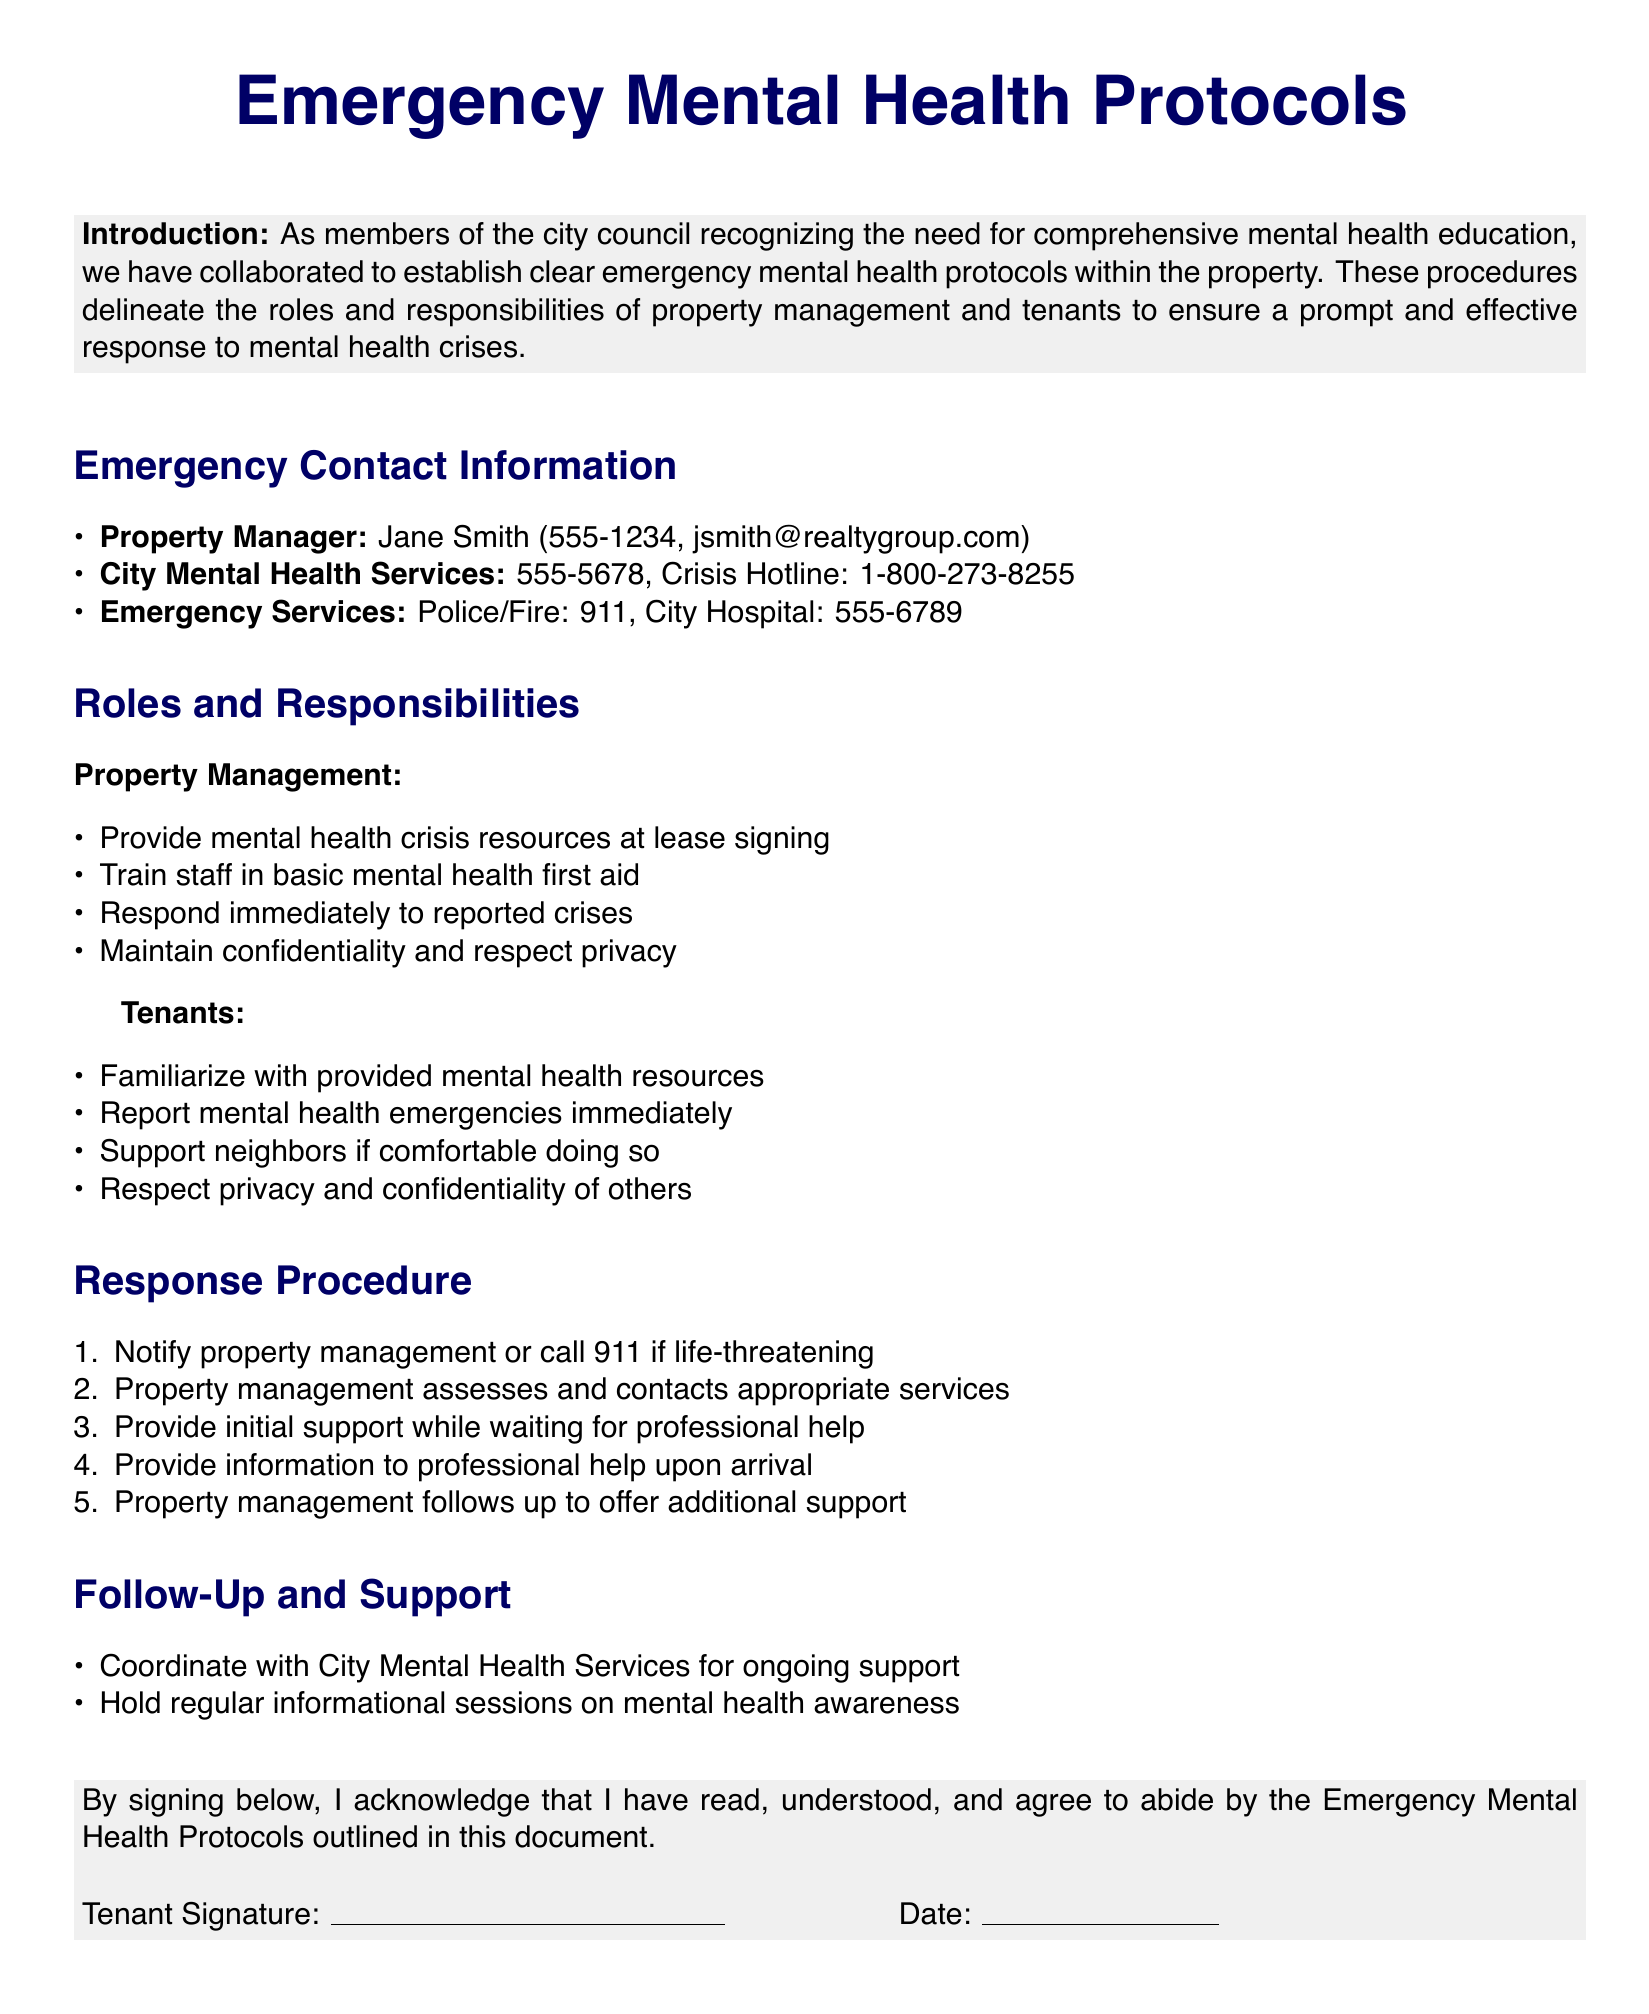What is the name of the property manager? The property manager's name is listed in the document under "Emergency Contact Information."
Answer: Jane Smith What is the phone number for City Mental Health Services? The phone number for City Mental Health Services is found in the emergency contact information section.
Answer: 555-5678 What should tenants do if they are aware of a mental health emergency? The responsibilities of tenants include reporting any mental health emergencies as outlined in their section.
Answer: Report immediately Who is responsible for training staff in basic mental health first aid? The document specifies roles under property management, indicating who is responsible for this training.
Answer: Property Management What is the first step in the response procedure for a mental health crisis? The response procedure outlines a specific order of actions; the first step is stated clearly.
Answer: Notify property management or call 911 How does property management follow up after a crisis? The document states the follow-up procedure includes a specific action provided by property management.
Answer: Offer additional support What type of sessions will be held for ongoing mental health awareness? The document mentions that specific types of sessions will occur, focusing on mental health education.
Answer: Informational sessions What must tenants do regarding confidentiality? The responsibilities for respecting confidentiality are explicitly mentioned under their role in the document.
Answer: Respect privacy and confidentiality What service should be contacted if life-threatening? The document reviews procedures and identifies the service that should be contacted in such a scenario.
Answer: 911 